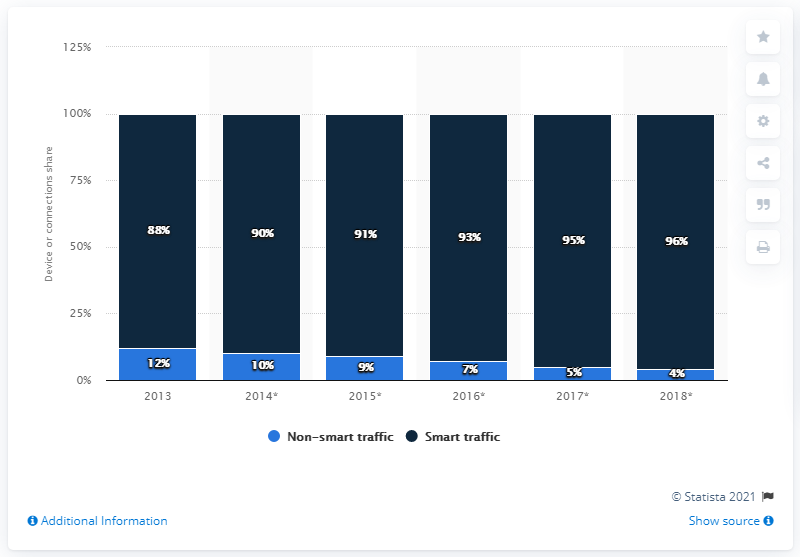Highlight a few significant elements in this photo. The highest reported percentage of smart traffic is 96%. In the year 2013, 88 percent of global mobile traffic originated from smart mobile devices. The average of non-smart traffic is 7.8. The projected growth of the share of smart mobile device traffic in 2018 is expected to be 96%. 